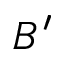Convert formula to latex. <formula><loc_0><loc_0><loc_500><loc_500>B ^ { \prime }</formula> 